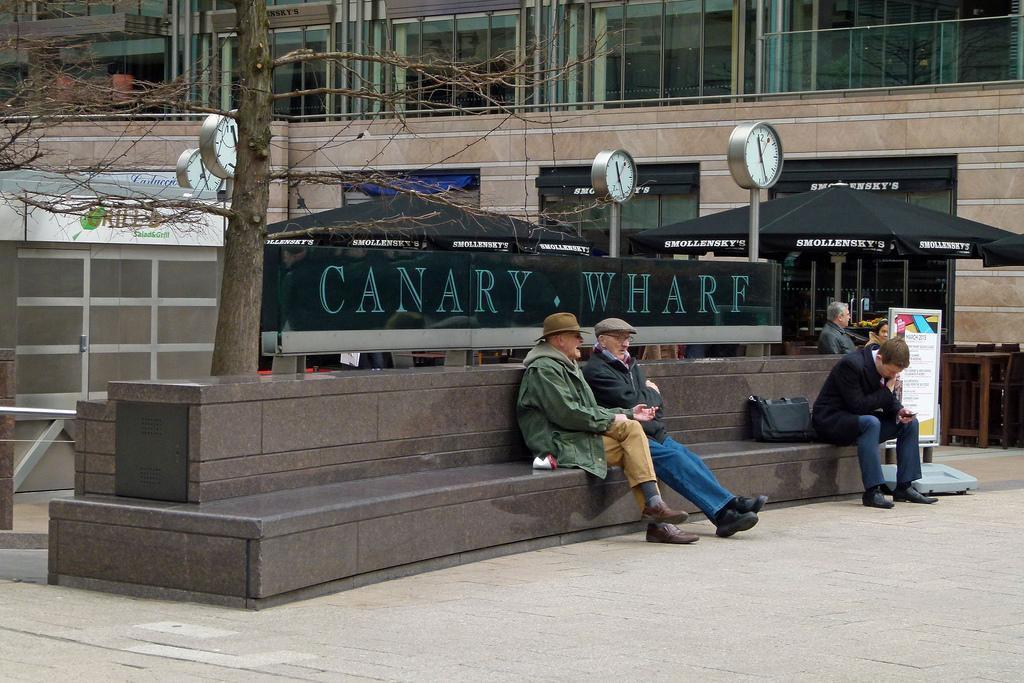How many people are wearing hats in the image?
Give a very brief answer. 2. 